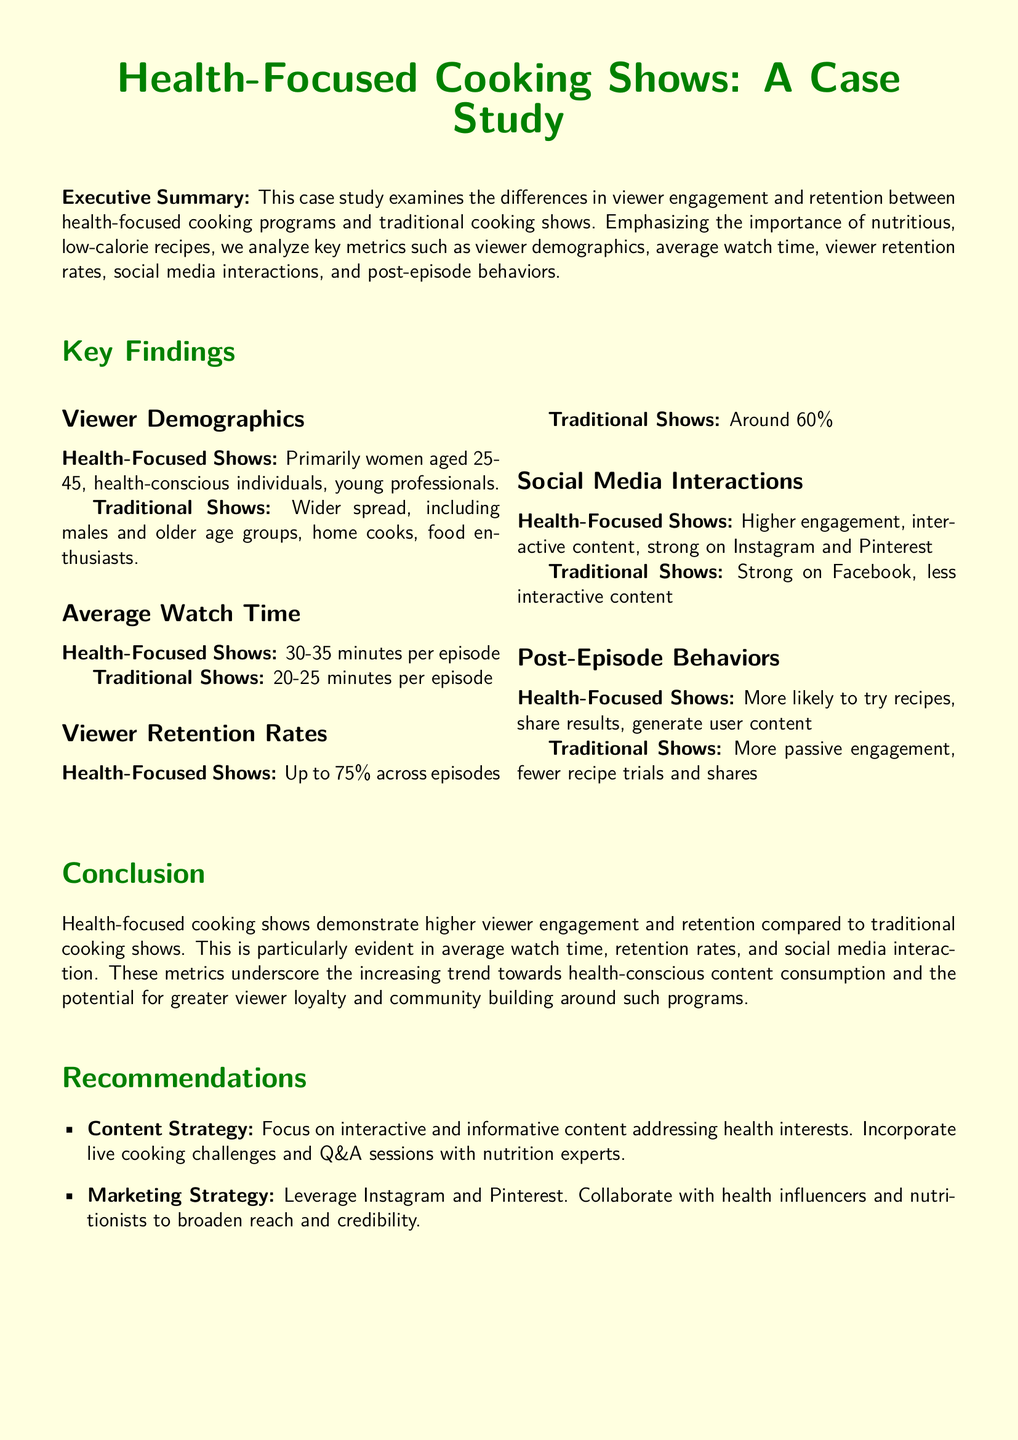what is the primary demographic for health-focused shows? The primary demographic for health-focused shows is women aged 25-45, health-conscious individuals, and young professionals.
Answer: women aged 25-45 what is the average watch time for traditional shows? The average watch time for traditional shows is stated as 20-25 minutes per episode.
Answer: 20-25 minutes what is the viewer retention rate for health-focused shows? The viewer retention rate for health-focused shows is indicated as up to 75% across episodes.
Answer: 75% which social media platforms show higher engagement for health-focused shows? Health-focused shows have higher engagement on Instagram and Pinterest.
Answer: Instagram and Pinterest what is a key post-episode behavior for viewers of health-focused shows? Viewers of health-focused shows are more likely to try recipes, share results, and generate user content.
Answer: try recipes what is one recommendation for the content strategy of health-focused shows? One recommendation for the content strategy is to incorporate live cooking challenges and Q&A sessions with nutrition experts.
Answer: live cooking challenges which group shows more passive engagement, health-focused or traditional shows? Traditional shows exhibit more passive engagement than health-focused shows.
Answer: traditional shows what should be leveraged for marketing health-focused shows? The marketing strategy should leverage Instagram and Pinterest.
Answer: Instagram and Pinterest how do viewer demographics differ between health-focused and traditional shows? Health-focused shows primarily attract younger, health-conscious demographics, while traditional shows have a wider spread, including older age groups and male viewers.
Answer: younger, health-conscious vs. wider spread 